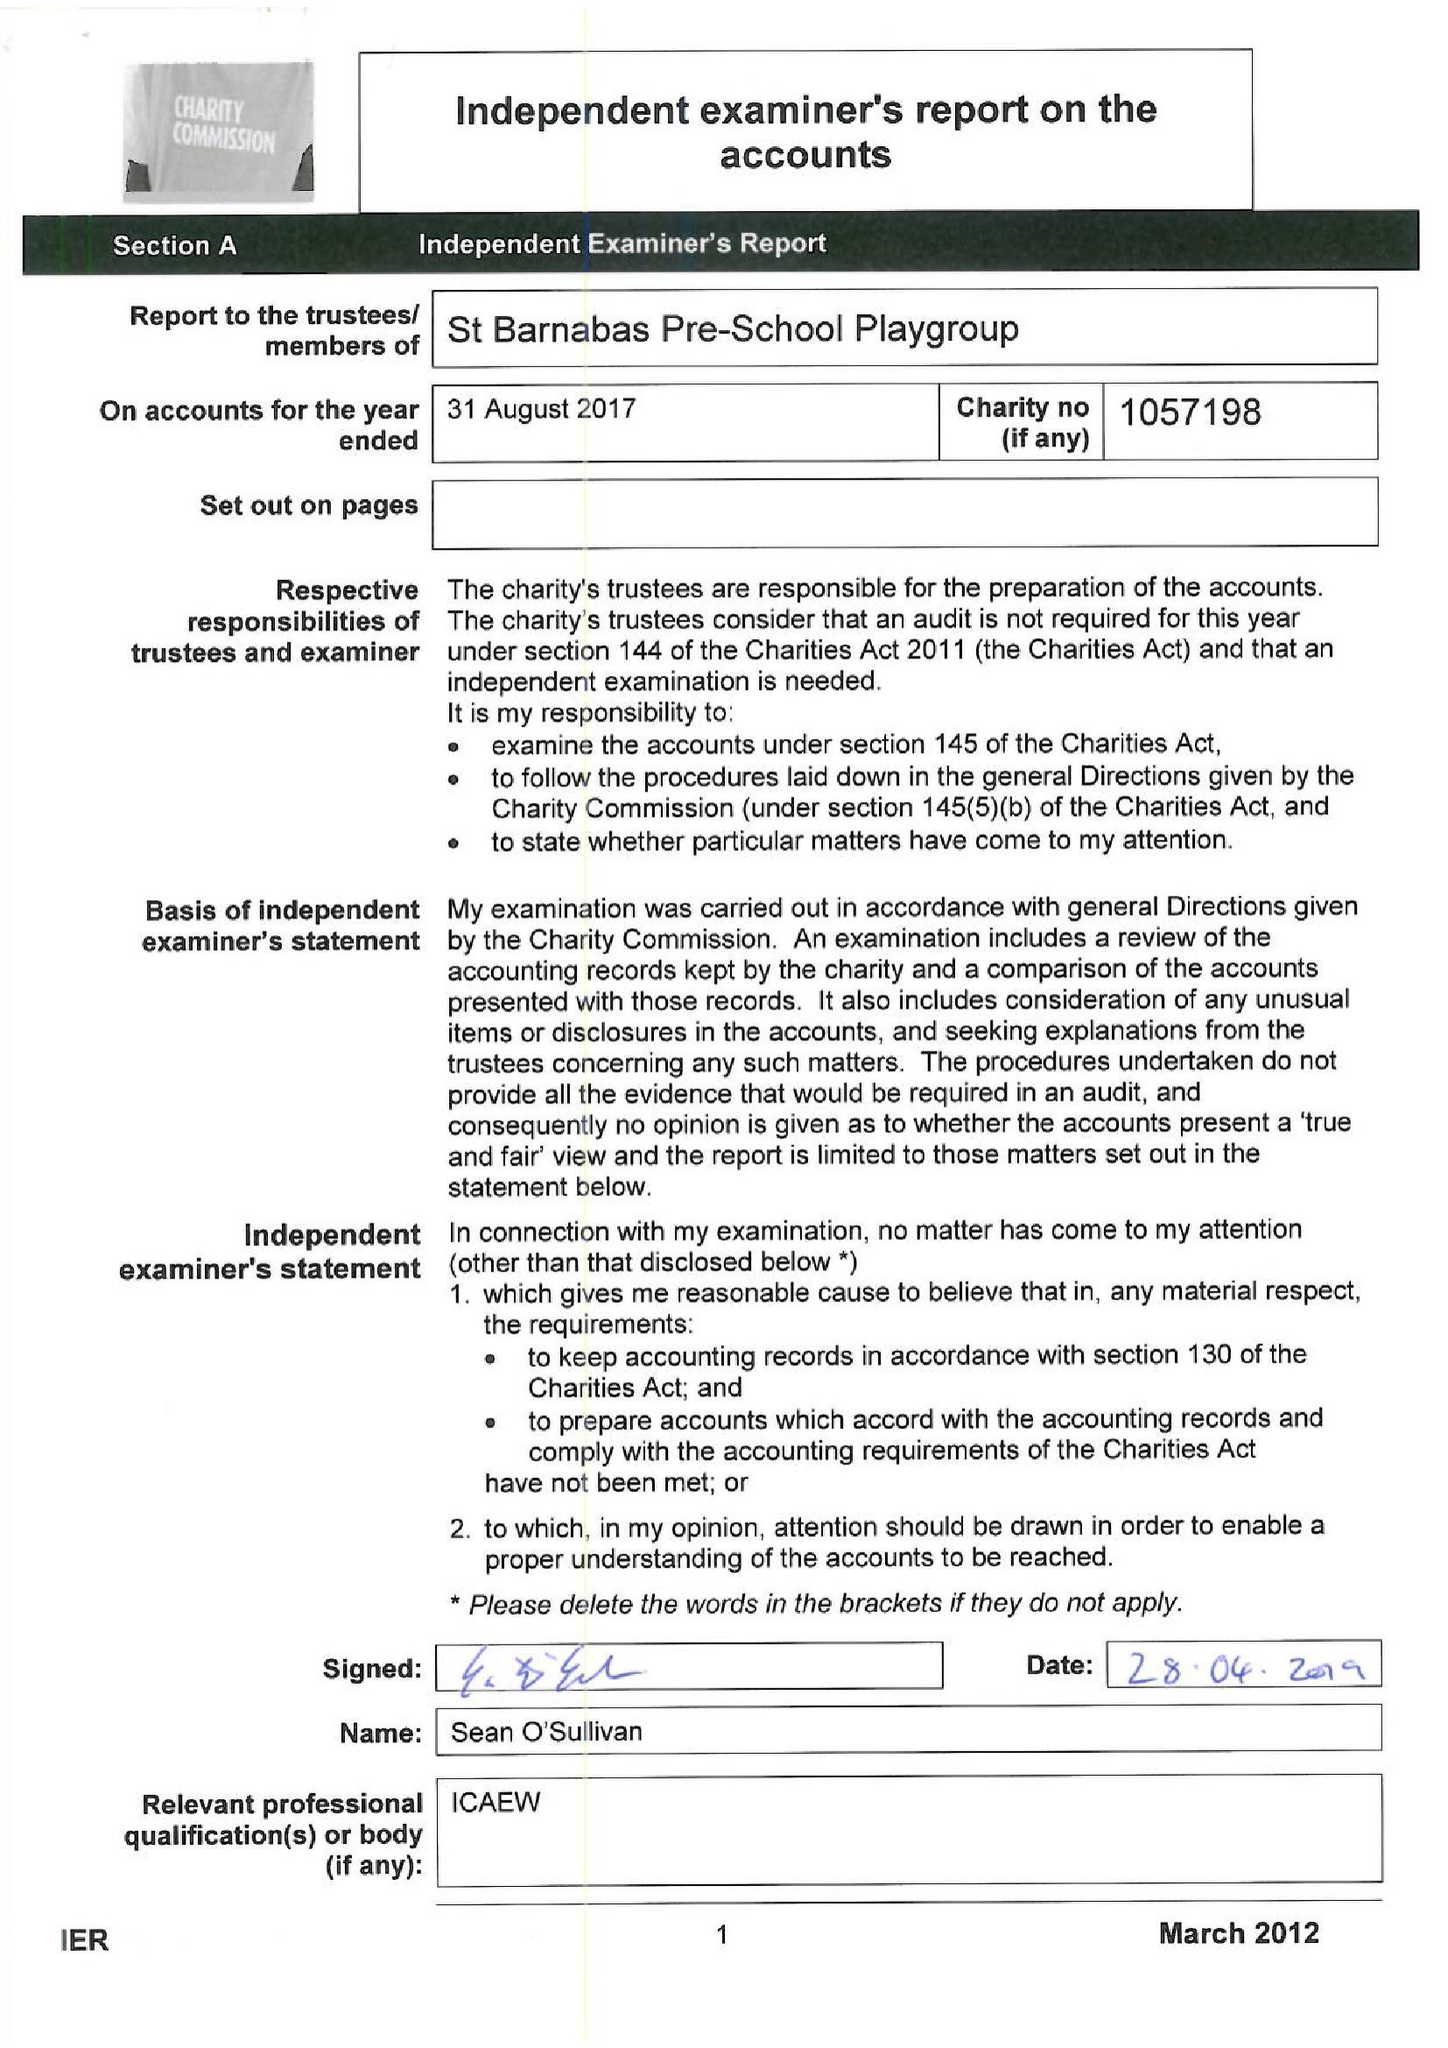What is the value for the charity_name?
Answer the question using a single word or phrase. St Barnabas Pre School Playgroup 